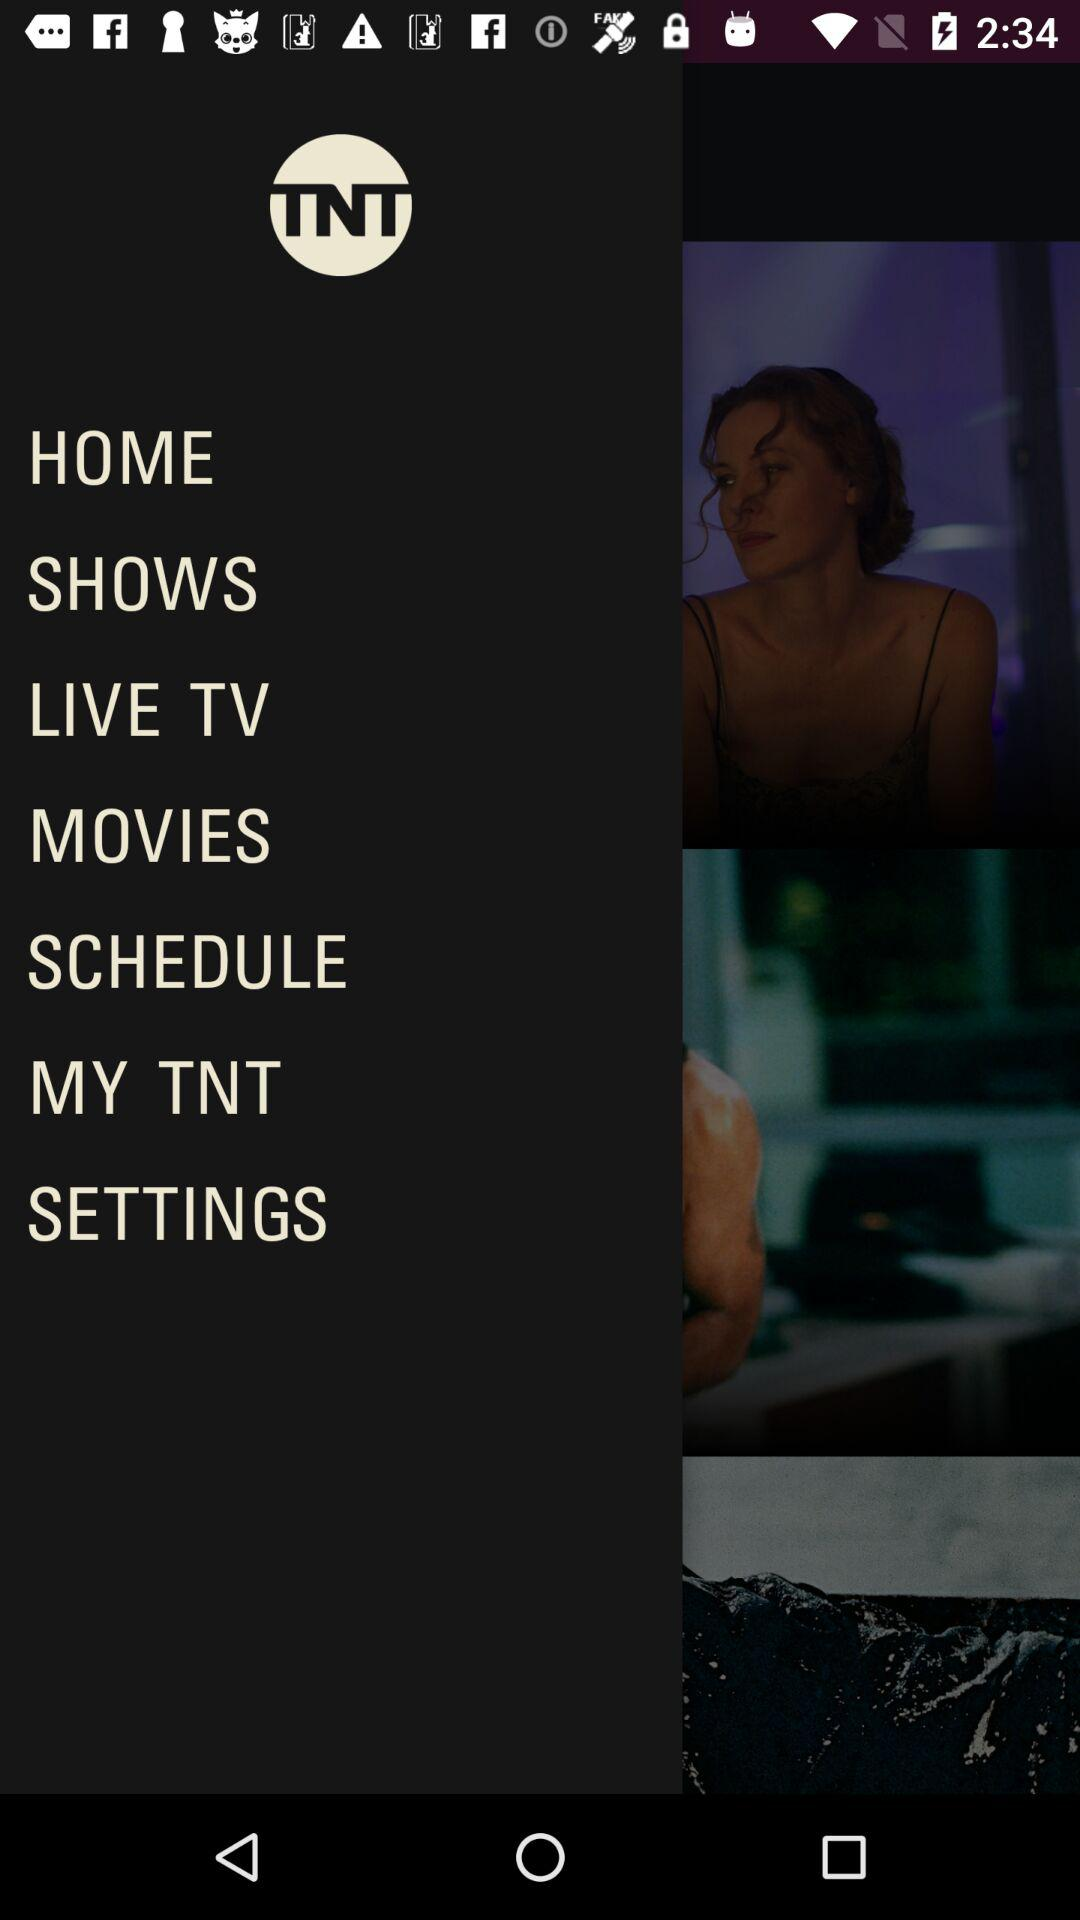What is the name of the application? The name of the application is "TNT". 